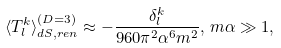Convert formula to latex. <formula><loc_0><loc_0><loc_500><loc_500>\langle T _ { l } ^ { k } \rangle _ { d S , r e n } ^ { ( D = 3 ) } \approx - \frac { \delta _ { l } ^ { k } } { 9 6 0 \pi ^ { 2 } \alpha ^ { 6 } m ^ { 2 } } , \, m \alpha \gg 1 ,</formula> 